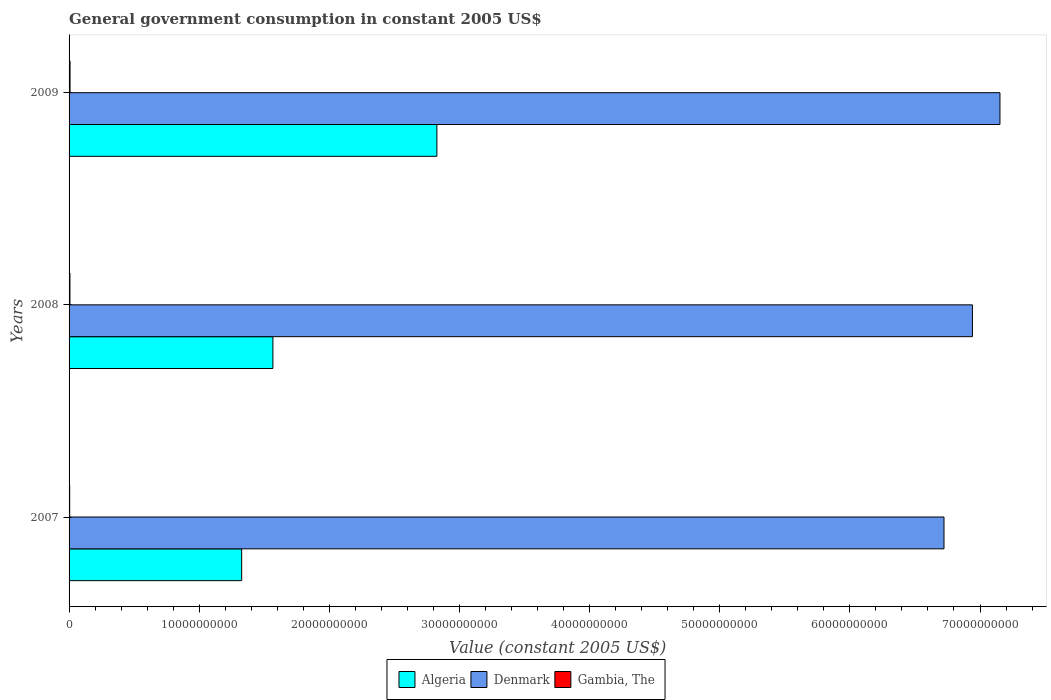How many groups of bars are there?
Keep it short and to the point. 3. What is the label of the 1st group of bars from the top?
Offer a very short reply. 2009. What is the government conusmption in Denmark in 2009?
Make the answer very short. 7.15e+1. Across all years, what is the maximum government conusmption in Gambia, The?
Your answer should be very brief. 7.48e+07. Across all years, what is the minimum government conusmption in Denmark?
Offer a very short reply. 6.72e+1. What is the total government conusmption in Algeria in the graph?
Provide a succinct answer. 5.72e+1. What is the difference between the government conusmption in Gambia, The in 2008 and that in 2009?
Provide a short and direct response. -9.83e+06. What is the difference between the government conusmption in Denmark in 2008 and the government conusmption in Algeria in 2007?
Offer a terse response. 5.62e+1. What is the average government conusmption in Gambia, The per year?
Offer a very short reply. 6.22e+07. In the year 2007, what is the difference between the government conusmption in Gambia, The and government conusmption in Denmark?
Offer a terse response. -6.72e+1. What is the ratio of the government conusmption in Gambia, The in 2008 to that in 2009?
Offer a very short reply. 0.87. Is the government conusmption in Denmark in 2007 less than that in 2009?
Provide a succinct answer. Yes. What is the difference between the highest and the second highest government conusmption in Gambia, The?
Make the answer very short. 9.83e+06. What is the difference between the highest and the lowest government conusmption in Gambia, The?
Give a very brief answer. 2.80e+07. Is the sum of the government conusmption in Denmark in 2007 and 2008 greater than the maximum government conusmption in Algeria across all years?
Your response must be concise. Yes. What does the 1st bar from the top in 2007 represents?
Make the answer very short. Gambia, The. What does the 2nd bar from the bottom in 2009 represents?
Offer a terse response. Denmark. What is the difference between two consecutive major ticks on the X-axis?
Provide a short and direct response. 1.00e+1. Are the values on the major ticks of X-axis written in scientific E-notation?
Your answer should be compact. No. Does the graph contain any zero values?
Ensure brevity in your answer.  No. Where does the legend appear in the graph?
Your answer should be compact. Bottom center. How are the legend labels stacked?
Provide a short and direct response. Horizontal. What is the title of the graph?
Keep it short and to the point. General government consumption in constant 2005 US$. What is the label or title of the X-axis?
Your answer should be compact. Value (constant 2005 US$). What is the label or title of the Y-axis?
Keep it short and to the point. Years. What is the Value (constant 2005 US$) in Algeria in 2007?
Make the answer very short. 1.33e+1. What is the Value (constant 2005 US$) of Denmark in 2007?
Your response must be concise. 6.72e+1. What is the Value (constant 2005 US$) in Gambia, The in 2007?
Offer a very short reply. 4.68e+07. What is the Value (constant 2005 US$) in Algeria in 2008?
Offer a very short reply. 1.57e+1. What is the Value (constant 2005 US$) in Denmark in 2008?
Offer a terse response. 6.94e+1. What is the Value (constant 2005 US$) of Gambia, The in 2008?
Provide a short and direct response. 6.50e+07. What is the Value (constant 2005 US$) in Algeria in 2009?
Provide a succinct answer. 2.83e+1. What is the Value (constant 2005 US$) of Denmark in 2009?
Your answer should be very brief. 7.15e+1. What is the Value (constant 2005 US$) in Gambia, The in 2009?
Provide a short and direct response. 7.48e+07. Across all years, what is the maximum Value (constant 2005 US$) of Algeria?
Provide a short and direct response. 2.83e+1. Across all years, what is the maximum Value (constant 2005 US$) of Denmark?
Keep it short and to the point. 7.15e+1. Across all years, what is the maximum Value (constant 2005 US$) of Gambia, The?
Your answer should be very brief. 7.48e+07. Across all years, what is the minimum Value (constant 2005 US$) of Algeria?
Give a very brief answer. 1.33e+1. Across all years, what is the minimum Value (constant 2005 US$) of Denmark?
Your answer should be compact. 6.72e+1. Across all years, what is the minimum Value (constant 2005 US$) of Gambia, The?
Give a very brief answer. 4.68e+07. What is the total Value (constant 2005 US$) in Algeria in the graph?
Offer a terse response. 5.72e+1. What is the total Value (constant 2005 US$) in Denmark in the graph?
Provide a succinct answer. 2.08e+11. What is the total Value (constant 2005 US$) in Gambia, The in the graph?
Ensure brevity in your answer.  1.87e+08. What is the difference between the Value (constant 2005 US$) in Algeria in 2007 and that in 2008?
Make the answer very short. -2.40e+09. What is the difference between the Value (constant 2005 US$) of Denmark in 2007 and that in 2008?
Ensure brevity in your answer.  -2.18e+09. What is the difference between the Value (constant 2005 US$) in Gambia, The in 2007 and that in 2008?
Ensure brevity in your answer.  -1.81e+07. What is the difference between the Value (constant 2005 US$) in Algeria in 2007 and that in 2009?
Make the answer very short. -1.50e+1. What is the difference between the Value (constant 2005 US$) of Denmark in 2007 and that in 2009?
Ensure brevity in your answer.  -4.30e+09. What is the difference between the Value (constant 2005 US$) in Gambia, The in 2007 and that in 2009?
Offer a very short reply. -2.80e+07. What is the difference between the Value (constant 2005 US$) in Algeria in 2008 and that in 2009?
Make the answer very short. -1.26e+1. What is the difference between the Value (constant 2005 US$) in Denmark in 2008 and that in 2009?
Your answer should be compact. -2.11e+09. What is the difference between the Value (constant 2005 US$) of Gambia, The in 2008 and that in 2009?
Provide a short and direct response. -9.83e+06. What is the difference between the Value (constant 2005 US$) of Algeria in 2007 and the Value (constant 2005 US$) of Denmark in 2008?
Ensure brevity in your answer.  -5.62e+1. What is the difference between the Value (constant 2005 US$) in Algeria in 2007 and the Value (constant 2005 US$) in Gambia, The in 2008?
Keep it short and to the point. 1.32e+1. What is the difference between the Value (constant 2005 US$) of Denmark in 2007 and the Value (constant 2005 US$) of Gambia, The in 2008?
Offer a terse response. 6.72e+1. What is the difference between the Value (constant 2005 US$) of Algeria in 2007 and the Value (constant 2005 US$) of Denmark in 2009?
Ensure brevity in your answer.  -5.83e+1. What is the difference between the Value (constant 2005 US$) of Algeria in 2007 and the Value (constant 2005 US$) of Gambia, The in 2009?
Make the answer very short. 1.32e+1. What is the difference between the Value (constant 2005 US$) of Denmark in 2007 and the Value (constant 2005 US$) of Gambia, The in 2009?
Keep it short and to the point. 6.72e+1. What is the difference between the Value (constant 2005 US$) in Algeria in 2008 and the Value (constant 2005 US$) in Denmark in 2009?
Your answer should be compact. -5.59e+1. What is the difference between the Value (constant 2005 US$) in Algeria in 2008 and the Value (constant 2005 US$) in Gambia, The in 2009?
Your response must be concise. 1.56e+1. What is the difference between the Value (constant 2005 US$) of Denmark in 2008 and the Value (constant 2005 US$) of Gambia, The in 2009?
Provide a short and direct response. 6.93e+1. What is the average Value (constant 2005 US$) in Algeria per year?
Your answer should be very brief. 1.91e+1. What is the average Value (constant 2005 US$) of Denmark per year?
Make the answer very short. 6.94e+1. What is the average Value (constant 2005 US$) in Gambia, The per year?
Provide a succinct answer. 6.22e+07. In the year 2007, what is the difference between the Value (constant 2005 US$) in Algeria and Value (constant 2005 US$) in Denmark?
Your answer should be compact. -5.40e+1. In the year 2007, what is the difference between the Value (constant 2005 US$) of Algeria and Value (constant 2005 US$) of Gambia, The?
Offer a very short reply. 1.32e+1. In the year 2007, what is the difference between the Value (constant 2005 US$) of Denmark and Value (constant 2005 US$) of Gambia, The?
Give a very brief answer. 6.72e+1. In the year 2008, what is the difference between the Value (constant 2005 US$) of Algeria and Value (constant 2005 US$) of Denmark?
Offer a terse response. -5.38e+1. In the year 2008, what is the difference between the Value (constant 2005 US$) in Algeria and Value (constant 2005 US$) in Gambia, The?
Keep it short and to the point. 1.56e+1. In the year 2008, what is the difference between the Value (constant 2005 US$) of Denmark and Value (constant 2005 US$) of Gambia, The?
Your response must be concise. 6.94e+1. In the year 2009, what is the difference between the Value (constant 2005 US$) in Algeria and Value (constant 2005 US$) in Denmark?
Keep it short and to the point. -4.33e+1. In the year 2009, what is the difference between the Value (constant 2005 US$) of Algeria and Value (constant 2005 US$) of Gambia, The?
Provide a short and direct response. 2.82e+1. In the year 2009, what is the difference between the Value (constant 2005 US$) in Denmark and Value (constant 2005 US$) in Gambia, The?
Ensure brevity in your answer.  7.15e+1. What is the ratio of the Value (constant 2005 US$) in Algeria in 2007 to that in 2008?
Offer a very short reply. 0.85. What is the ratio of the Value (constant 2005 US$) in Denmark in 2007 to that in 2008?
Give a very brief answer. 0.97. What is the ratio of the Value (constant 2005 US$) in Gambia, The in 2007 to that in 2008?
Provide a succinct answer. 0.72. What is the ratio of the Value (constant 2005 US$) of Algeria in 2007 to that in 2009?
Offer a very short reply. 0.47. What is the ratio of the Value (constant 2005 US$) in Denmark in 2007 to that in 2009?
Keep it short and to the point. 0.94. What is the ratio of the Value (constant 2005 US$) in Gambia, The in 2007 to that in 2009?
Offer a very short reply. 0.63. What is the ratio of the Value (constant 2005 US$) of Algeria in 2008 to that in 2009?
Make the answer very short. 0.55. What is the ratio of the Value (constant 2005 US$) of Denmark in 2008 to that in 2009?
Keep it short and to the point. 0.97. What is the ratio of the Value (constant 2005 US$) of Gambia, The in 2008 to that in 2009?
Offer a very short reply. 0.87. What is the difference between the highest and the second highest Value (constant 2005 US$) in Algeria?
Provide a succinct answer. 1.26e+1. What is the difference between the highest and the second highest Value (constant 2005 US$) in Denmark?
Offer a very short reply. 2.11e+09. What is the difference between the highest and the second highest Value (constant 2005 US$) in Gambia, The?
Your response must be concise. 9.83e+06. What is the difference between the highest and the lowest Value (constant 2005 US$) of Algeria?
Keep it short and to the point. 1.50e+1. What is the difference between the highest and the lowest Value (constant 2005 US$) in Denmark?
Provide a succinct answer. 4.30e+09. What is the difference between the highest and the lowest Value (constant 2005 US$) in Gambia, The?
Ensure brevity in your answer.  2.80e+07. 